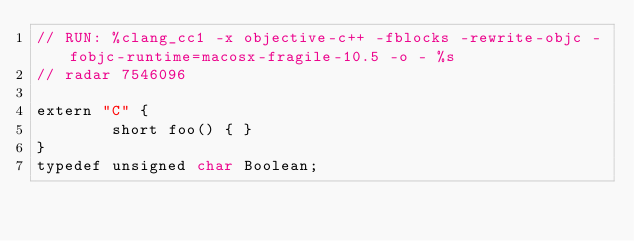<code> <loc_0><loc_0><loc_500><loc_500><_ObjectiveC_>// RUN: %clang_cc1 -x objective-c++ -fblocks -rewrite-objc -fobjc-runtime=macosx-fragile-10.5 -o - %s
// radar 7546096

extern "C" {
        short foo() { } 
}
typedef unsigned char Boolean;

</code> 